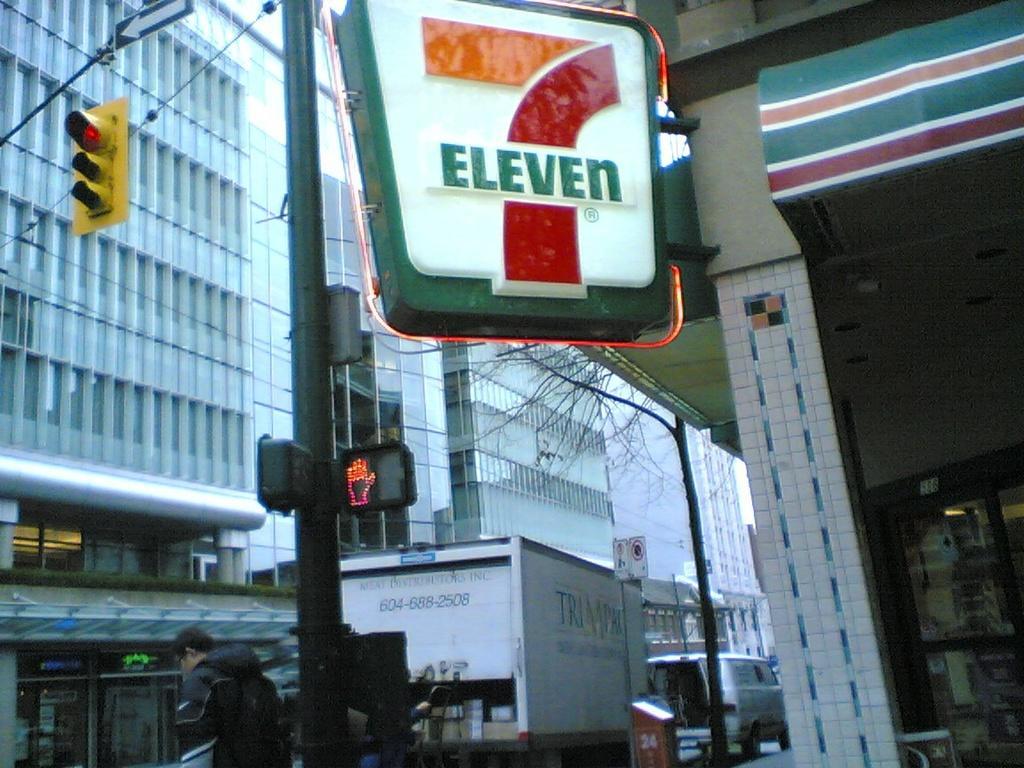Could you give a brief overview of what you see in this image? There is a sign pole in the foreground, there are vehicles, buildings, a person and a stall in the background area, there are poles on the left side. 